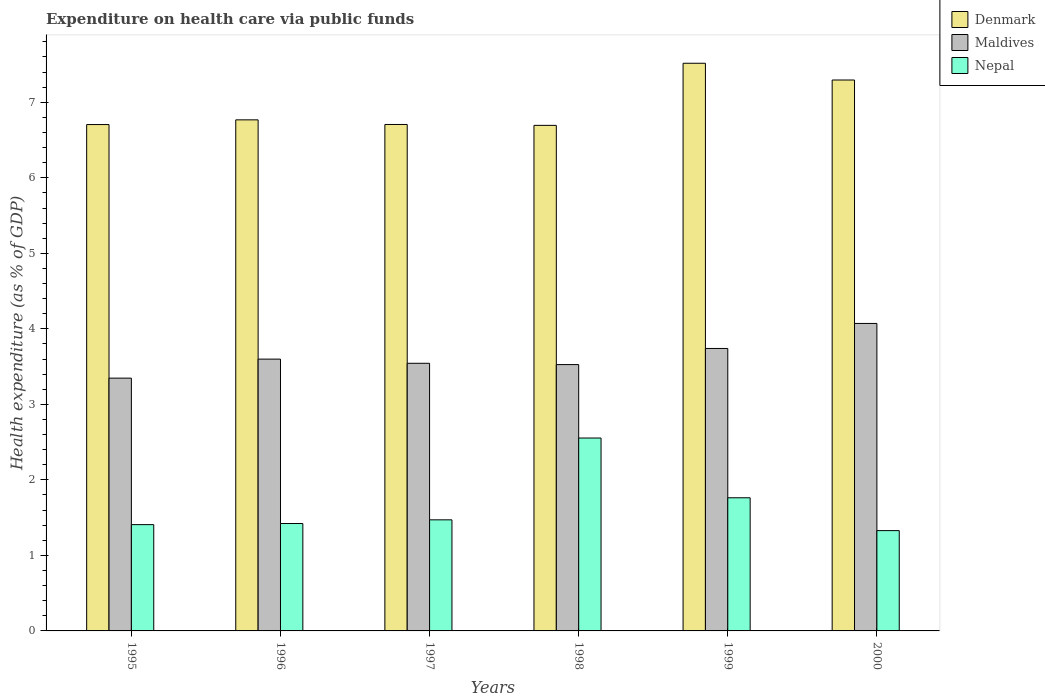How many groups of bars are there?
Provide a short and direct response. 6. Are the number of bars on each tick of the X-axis equal?
Make the answer very short. Yes. How many bars are there on the 3rd tick from the right?
Make the answer very short. 3. What is the label of the 2nd group of bars from the left?
Your response must be concise. 1996. What is the expenditure made on health care in Denmark in 1999?
Provide a short and direct response. 7.52. Across all years, what is the maximum expenditure made on health care in Denmark?
Give a very brief answer. 7.52. Across all years, what is the minimum expenditure made on health care in Nepal?
Your answer should be very brief. 1.33. In which year was the expenditure made on health care in Nepal maximum?
Offer a very short reply. 1998. What is the total expenditure made on health care in Denmark in the graph?
Give a very brief answer. 41.69. What is the difference between the expenditure made on health care in Maldives in 1998 and that in 1999?
Give a very brief answer. -0.21. What is the difference between the expenditure made on health care in Nepal in 2000 and the expenditure made on health care in Denmark in 1997?
Keep it short and to the point. -5.38. What is the average expenditure made on health care in Denmark per year?
Offer a terse response. 6.95. In the year 1999, what is the difference between the expenditure made on health care in Nepal and expenditure made on health care in Maldives?
Offer a very short reply. -1.98. In how many years, is the expenditure made on health care in Nepal greater than 6.4 %?
Provide a short and direct response. 0. What is the ratio of the expenditure made on health care in Denmark in 1995 to that in 2000?
Provide a short and direct response. 0.92. Is the expenditure made on health care in Maldives in 1995 less than that in 1998?
Your answer should be compact. Yes. What is the difference between the highest and the second highest expenditure made on health care in Nepal?
Make the answer very short. 0.79. What is the difference between the highest and the lowest expenditure made on health care in Maldives?
Your answer should be compact. 0.72. In how many years, is the expenditure made on health care in Nepal greater than the average expenditure made on health care in Nepal taken over all years?
Give a very brief answer. 2. Is the sum of the expenditure made on health care in Nepal in 1995 and 1998 greater than the maximum expenditure made on health care in Maldives across all years?
Your response must be concise. No. What does the 2nd bar from the left in 1996 represents?
Your answer should be compact. Maldives. What does the 1st bar from the right in 1998 represents?
Your answer should be compact. Nepal. Is it the case that in every year, the sum of the expenditure made on health care in Denmark and expenditure made on health care in Maldives is greater than the expenditure made on health care in Nepal?
Give a very brief answer. Yes. How many bars are there?
Keep it short and to the point. 18. Are all the bars in the graph horizontal?
Ensure brevity in your answer.  No. What is the difference between two consecutive major ticks on the Y-axis?
Your answer should be very brief. 1. Are the values on the major ticks of Y-axis written in scientific E-notation?
Your answer should be very brief. No. Does the graph contain grids?
Make the answer very short. No. Where does the legend appear in the graph?
Your answer should be compact. Top right. How are the legend labels stacked?
Make the answer very short. Vertical. What is the title of the graph?
Your answer should be very brief. Expenditure on health care via public funds. What is the label or title of the X-axis?
Provide a short and direct response. Years. What is the label or title of the Y-axis?
Keep it short and to the point. Health expenditure (as % of GDP). What is the Health expenditure (as % of GDP) of Denmark in 1995?
Your answer should be compact. 6.71. What is the Health expenditure (as % of GDP) in Maldives in 1995?
Offer a terse response. 3.35. What is the Health expenditure (as % of GDP) in Nepal in 1995?
Your answer should be very brief. 1.41. What is the Health expenditure (as % of GDP) of Denmark in 1996?
Your answer should be very brief. 6.77. What is the Health expenditure (as % of GDP) of Maldives in 1996?
Keep it short and to the point. 3.6. What is the Health expenditure (as % of GDP) in Nepal in 1996?
Provide a succinct answer. 1.42. What is the Health expenditure (as % of GDP) in Denmark in 1997?
Offer a very short reply. 6.71. What is the Health expenditure (as % of GDP) of Maldives in 1997?
Your answer should be compact. 3.54. What is the Health expenditure (as % of GDP) of Nepal in 1997?
Provide a succinct answer. 1.47. What is the Health expenditure (as % of GDP) of Denmark in 1998?
Your answer should be very brief. 6.69. What is the Health expenditure (as % of GDP) in Maldives in 1998?
Your response must be concise. 3.53. What is the Health expenditure (as % of GDP) of Nepal in 1998?
Offer a terse response. 2.55. What is the Health expenditure (as % of GDP) in Denmark in 1999?
Ensure brevity in your answer.  7.52. What is the Health expenditure (as % of GDP) of Maldives in 1999?
Provide a succinct answer. 3.74. What is the Health expenditure (as % of GDP) in Nepal in 1999?
Offer a very short reply. 1.76. What is the Health expenditure (as % of GDP) in Denmark in 2000?
Your response must be concise. 7.3. What is the Health expenditure (as % of GDP) of Maldives in 2000?
Give a very brief answer. 4.07. What is the Health expenditure (as % of GDP) in Nepal in 2000?
Keep it short and to the point. 1.33. Across all years, what is the maximum Health expenditure (as % of GDP) of Denmark?
Your answer should be very brief. 7.52. Across all years, what is the maximum Health expenditure (as % of GDP) of Maldives?
Ensure brevity in your answer.  4.07. Across all years, what is the maximum Health expenditure (as % of GDP) in Nepal?
Ensure brevity in your answer.  2.55. Across all years, what is the minimum Health expenditure (as % of GDP) in Denmark?
Ensure brevity in your answer.  6.69. Across all years, what is the minimum Health expenditure (as % of GDP) in Maldives?
Your response must be concise. 3.35. Across all years, what is the minimum Health expenditure (as % of GDP) in Nepal?
Make the answer very short. 1.33. What is the total Health expenditure (as % of GDP) in Denmark in the graph?
Your answer should be compact. 41.69. What is the total Health expenditure (as % of GDP) of Maldives in the graph?
Offer a very short reply. 21.83. What is the total Health expenditure (as % of GDP) of Nepal in the graph?
Provide a short and direct response. 9.95. What is the difference between the Health expenditure (as % of GDP) of Denmark in 1995 and that in 1996?
Your answer should be compact. -0.06. What is the difference between the Health expenditure (as % of GDP) in Maldives in 1995 and that in 1996?
Your response must be concise. -0.25. What is the difference between the Health expenditure (as % of GDP) of Nepal in 1995 and that in 1996?
Make the answer very short. -0.01. What is the difference between the Health expenditure (as % of GDP) in Denmark in 1995 and that in 1997?
Your answer should be compact. -0. What is the difference between the Health expenditure (as % of GDP) of Maldives in 1995 and that in 1997?
Keep it short and to the point. -0.2. What is the difference between the Health expenditure (as % of GDP) of Nepal in 1995 and that in 1997?
Keep it short and to the point. -0.06. What is the difference between the Health expenditure (as % of GDP) in Denmark in 1995 and that in 1998?
Provide a succinct answer. 0.01. What is the difference between the Health expenditure (as % of GDP) in Maldives in 1995 and that in 1998?
Provide a short and direct response. -0.18. What is the difference between the Health expenditure (as % of GDP) of Nepal in 1995 and that in 1998?
Ensure brevity in your answer.  -1.15. What is the difference between the Health expenditure (as % of GDP) of Denmark in 1995 and that in 1999?
Your answer should be compact. -0.81. What is the difference between the Health expenditure (as % of GDP) in Maldives in 1995 and that in 1999?
Keep it short and to the point. -0.39. What is the difference between the Health expenditure (as % of GDP) of Nepal in 1995 and that in 1999?
Keep it short and to the point. -0.36. What is the difference between the Health expenditure (as % of GDP) in Denmark in 1995 and that in 2000?
Ensure brevity in your answer.  -0.59. What is the difference between the Health expenditure (as % of GDP) of Maldives in 1995 and that in 2000?
Ensure brevity in your answer.  -0.72. What is the difference between the Health expenditure (as % of GDP) of Nepal in 1995 and that in 2000?
Keep it short and to the point. 0.08. What is the difference between the Health expenditure (as % of GDP) of Denmark in 1996 and that in 1997?
Offer a terse response. 0.06. What is the difference between the Health expenditure (as % of GDP) of Maldives in 1996 and that in 1997?
Provide a succinct answer. 0.06. What is the difference between the Health expenditure (as % of GDP) in Nepal in 1996 and that in 1997?
Provide a short and direct response. -0.05. What is the difference between the Health expenditure (as % of GDP) in Denmark in 1996 and that in 1998?
Your answer should be compact. 0.07. What is the difference between the Health expenditure (as % of GDP) of Maldives in 1996 and that in 1998?
Your response must be concise. 0.07. What is the difference between the Health expenditure (as % of GDP) in Nepal in 1996 and that in 1998?
Your answer should be very brief. -1.13. What is the difference between the Health expenditure (as % of GDP) of Denmark in 1996 and that in 1999?
Keep it short and to the point. -0.75. What is the difference between the Health expenditure (as % of GDP) in Maldives in 1996 and that in 1999?
Ensure brevity in your answer.  -0.14. What is the difference between the Health expenditure (as % of GDP) in Nepal in 1996 and that in 1999?
Give a very brief answer. -0.34. What is the difference between the Health expenditure (as % of GDP) in Denmark in 1996 and that in 2000?
Provide a short and direct response. -0.53. What is the difference between the Health expenditure (as % of GDP) of Maldives in 1996 and that in 2000?
Keep it short and to the point. -0.47. What is the difference between the Health expenditure (as % of GDP) in Nepal in 1996 and that in 2000?
Offer a terse response. 0.09. What is the difference between the Health expenditure (as % of GDP) in Denmark in 1997 and that in 1998?
Provide a succinct answer. 0.01. What is the difference between the Health expenditure (as % of GDP) in Maldives in 1997 and that in 1998?
Your response must be concise. 0.02. What is the difference between the Health expenditure (as % of GDP) in Nepal in 1997 and that in 1998?
Your response must be concise. -1.08. What is the difference between the Health expenditure (as % of GDP) in Denmark in 1997 and that in 1999?
Provide a succinct answer. -0.81. What is the difference between the Health expenditure (as % of GDP) in Maldives in 1997 and that in 1999?
Offer a terse response. -0.2. What is the difference between the Health expenditure (as % of GDP) of Nepal in 1997 and that in 1999?
Your answer should be very brief. -0.29. What is the difference between the Health expenditure (as % of GDP) in Denmark in 1997 and that in 2000?
Provide a short and direct response. -0.59. What is the difference between the Health expenditure (as % of GDP) in Maldives in 1997 and that in 2000?
Give a very brief answer. -0.53. What is the difference between the Health expenditure (as % of GDP) of Nepal in 1997 and that in 2000?
Ensure brevity in your answer.  0.14. What is the difference between the Health expenditure (as % of GDP) of Denmark in 1998 and that in 1999?
Provide a succinct answer. -0.82. What is the difference between the Health expenditure (as % of GDP) of Maldives in 1998 and that in 1999?
Ensure brevity in your answer.  -0.21. What is the difference between the Health expenditure (as % of GDP) in Nepal in 1998 and that in 1999?
Offer a terse response. 0.79. What is the difference between the Health expenditure (as % of GDP) of Denmark in 1998 and that in 2000?
Provide a short and direct response. -0.6. What is the difference between the Health expenditure (as % of GDP) of Maldives in 1998 and that in 2000?
Offer a terse response. -0.54. What is the difference between the Health expenditure (as % of GDP) in Nepal in 1998 and that in 2000?
Ensure brevity in your answer.  1.23. What is the difference between the Health expenditure (as % of GDP) in Denmark in 1999 and that in 2000?
Provide a short and direct response. 0.22. What is the difference between the Health expenditure (as % of GDP) in Maldives in 1999 and that in 2000?
Give a very brief answer. -0.33. What is the difference between the Health expenditure (as % of GDP) of Nepal in 1999 and that in 2000?
Your response must be concise. 0.44. What is the difference between the Health expenditure (as % of GDP) in Denmark in 1995 and the Health expenditure (as % of GDP) in Maldives in 1996?
Give a very brief answer. 3.11. What is the difference between the Health expenditure (as % of GDP) of Denmark in 1995 and the Health expenditure (as % of GDP) of Nepal in 1996?
Your response must be concise. 5.28. What is the difference between the Health expenditure (as % of GDP) in Maldives in 1995 and the Health expenditure (as % of GDP) in Nepal in 1996?
Provide a short and direct response. 1.93. What is the difference between the Health expenditure (as % of GDP) in Denmark in 1995 and the Health expenditure (as % of GDP) in Maldives in 1997?
Ensure brevity in your answer.  3.16. What is the difference between the Health expenditure (as % of GDP) of Denmark in 1995 and the Health expenditure (as % of GDP) of Nepal in 1997?
Keep it short and to the point. 5.23. What is the difference between the Health expenditure (as % of GDP) in Maldives in 1995 and the Health expenditure (as % of GDP) in Nepal in 1997?
Your response must be concise. 1.88. What is the difference between the Health expenditure (as % of GDP) in Denmark in 1995 and the Health expenditure (as % of GDP) in Maldives in 1998?
Ensure brevity in your answer.  3.18. What is the difference between the Health expenditure (as % of GDP) in Denmark in 1995 and the Health expenditure (as % of GDP) in Nepal in 1998?
Offer a very short reply. 4.15. What is the difference between the Health expenditure (as % of GDP) in Maldives in 1995 and the Health expenditure (as % of GDP) in Nepal in 1998?
Your answer should be very brief. 0.79. What is the difference between the Health expenditure (as % of GDP) in Denmark in 1995 and the Health expenditure (as % of GDP) in Maldives in 1999?
Your answer should be compact. 2.97. What is the difference between the Health expenditure (as % of GDP) in Denmark in 1995 and the Health expenditure (as % of GDP) in Nepal in 1999?
Provide a succinct answer. 4.94. What is the difference between the Health expenditure (as % of GDP) in Maldives in 1995 and the Health expenditure (as % of GDP) in Nepal in 1999?
Provide a succinct answer. 1.58. What is the difference between the Health expenditure (as % of GDP) of Denmark in 1995 and the Health expenditure (as % of GDP) of Maldives in 2000?
Provide a short and direct response. 2.63. What is the difference between the Health expenditure (as % of GDP) of Denmark in 1995 and the Health expenditure (as % of GDP) of Nepal in 2000?
Make the answer very short. 5.38. What is the difference between the Health expenditure (as % of GDP) in Maldives in 1995 and the Health expenditure (as % of GDP) in Nepal in 2000?
Ensure brevity in your answer.  2.02. What is the difference between the Health expenditure (as % of GDP) in Denmark in 1996 and the Health expenditure (as % of GDP) in Maldives in 1997?
Provide a succinct answer. 3.22. What is the difference between the Health expenditure (as % of GDP) in Denmark in 1996 and the Health expenditure (as % of GDP) in Nepal in 1997?
Give a very brief answer. 5.3. What is the difference between the Health expenditure (as % of GDP) of Maldives in 1996 and the Health expenditure (as % of GDP) of Nepal in 1997?
Ensure brevity in your answer.  2.13. What is the difference between the Health expenditure (as % of GDP) in Denmark in 1996 and the Health expenditure (as % of GDP) in Maldives in 1998?
Provide a short and direct response. 3.24. What is the difference between the Health expenditure (as % of GDP) of Denmark in 1996 and the Health expenditure (as % of GDP) of Nepal in 1998?
Offer a terse response. 4.21. What is the difference between the Health expenditure (as % of GDP) of Maldives in 1996 and the Health expenditure (as % of GDP) of Nepal in 1998?
Ensure brevity in your answer.  1.04. What is the difference between the Health expenditure (as % of GDP) in Denmark in 1996 and the Health expenditure (as % of GDP) in Maldives in 1999?
Make the answer very short. 3.03. What is the difference between the Health expenditure (as % of GDP) of Denmark in 1996 and the Health expenditure (as % of GDP) of Nepal in 1999?
Offer a terse response. 5. What is the difference between the Health expenditure (as % of GDP) in Maldives in 1996 and the Health expenditure (as % of GDP) in Nepal in 1999?
Your answer should be compact. 1.84. What is the difference between the Health expenditure (as % of GDP) of Denmark in 1996 and the Health expenditure (as % of GDP) of Maldives in 2000?
Offer a very short reply. 2.7. What is the difference between the Health expenditure (as % of GDP) in Denmark in 1996 and the Health expenditure (as % of GDP) in Nepal in 2000?
Provide a succinct answer. 5.44. What is the difference between the Health expenditure (as % of GDP) in Maldives in 1996 and the Health expenditure (as % of GDP) in Nepal in 2000?
Your answer should be very brief. 2.27. What is the difference between the Health expenditure (as % of GDP) in Denmark in 1997 and the Health expenditure (as % of GDP) in Maldives in 1998?
Offer a terse response. 3.18. What is the difference between the Health expenditure (as % of GDP) in Denmark in 1997 and the Health expenditure (as % of GDP) in Nepal in 1998?
Keep it short and to the point. 4.15. What is the difference between the Health expenditure (as % of GDP) in Denmark in 1997 and the Health expenditure (as % of GDP) in Maldives in 1999?
Your response must be concise. 2.97. What is the difference between the Health expenditure (as % of GDP) in Denmark in 1997 and the Health expenditure (as % of GDP) in Nepal in 1999?
Your answer should be compact. 4.94. What is the difference between the Health expenditure (as % of GDP) in Maldives in 1997 and the Health expenditure (as % of GDP) in Nepal in 1999?
Offer a very short reply. 1.78. What is the difference between the Health expenditure (as % of GDP) of Denmark in 1997 and the Health expenditure (as % of GDP) of Maldives in 2000?
Your response must be concise. 2.63. What is the difference between the Health expenditure (as % of GDP) of Denmark in 1997 and the Health expenditure (as % of GDP) of Nepal in 2000?
Make the answer very short. 5.38. What is the difference between the Health expenditure (as % of GDP) of Maldives in 1997 and the Health expenditure (as % of GDP) of Nepal in 2000?
Your response must be concise. 2.22. What is the difference between the Health expenditure (as % of GDP) in Denmark in 1998 and the Health expenditure (as % of GDP) in Maldives in 1999?
Give a very brief answer. 2.95. What is the difference between the Health expenditure (as % of GDP) in Denmark in 1998 and the Health expenditure (as % of GDP) in Nepal in 1999?
Ensure brevity in your answer.  4.93. What is the difference between the Health expenditure (as % of GDP) of Maldives in 1998 and the Health expenditure (as % of GDP) of Nepal in 1999?
Your answer should be compact. 1.76. What is the difference between the Health expenditure (as % of GDP) in Denmark in 1998 and the Health expenditure (as % of GDP) in Maldives in 2000?
Keep it short and to the point. 2.62. What is the difference between the Health expenditure (as % of GDP) of Denmark in 1998 and the Health expenditure (as % of GDP) of Nepal in 2000?
Your answer should be compact. 5.37. What is the difference between the Health expenditure (as % of GDP) in Maldives in 1998 and the Health expenditure (as % of GDP) in Nepal in 2000?
Provide a succinct answer. 2.2. What is the difference between the Health expenditure (as % of GDP) of Denmark in 1999 and the Health expenditure (as % of GDP) of Maldives in 2000?
Offer a terse response. 3.45. What is the difference between the Health expenditure (as % of GDP) in Denmark in 1999 and the Health expenditure (as % of GDP) in Nepal in 2000?
Provide a succinct answer. 6.19. What is the difference between the Health expenditure (as % of GDP) of Maldives in 1999 and the Health expenditure (as % of GDP) of Nepal in 2000?
Your answer should be very brief. 2.41. What is the average Health expenditure (as % of GDP) of Denmark per year?
Keep it short and to the point. 6.95. What is the average Health expenditure (as % of GDP) in Maldives per year?
Your response must be concise. 3.64. What is the average Health expenditure (as % of GDP) in Nepal per year?
Provide a succinct answer. 1.66. In the year 1995, what is the difference between the Health expenditure (as % of GDP) of Denmark and Health expenditure (as % of GDP) of Maldives?
Ensure brevity in your answer.  3.36. In the year 1995, what is the difference between the Health expenditure (as % of GDP) in Denmark and Health expenditure (as % of GDP) in Nepal?
Your answer should be compact. 5.3. In the year 1995, what is the difference between the Health expenditure (as % of GDP) of Maldives and Health expenditure (as % of GDP) of Nepal?
Your answer should be compact. 1.94. In the year 1996, what is the difference between the Health expenditure (as % of GDP) in Denmark and Health expenditure (as % of GDP) in Maldives?
Make the answer very short. 3.17. In the year 1996, what is the difference between the Health expenditure (as % of GDP) in Denmark and Health expenditure (as % of GDP) in Nepal?
Your answer should be very brief. 5.35. In the year 1996, what is the difference between the Health expenditure (as % of GDP) in Maldives and Health expenditure (as % of GDP) in Nepal?
Your answer should be very brief. 2.18. In the year 1997, what is the difference between the Health expenditure (as % of GDP) of Denmark and Health expenditure (as % of GDP) of Maldives?
Your answer should be very brief. 3.16. In the year 1997, what is the difference between the Health expenditure (as % of GDP) in Denmark and Health expenditure (as % of GDP) in Nepal?
Make the answer very short. 5.24. In the year 1997, what is the difference between the Health expenditure (as % of GDP) in Maldives and Health expenditure (as % of GDP) in Nepal?
Make the answer very short. 2.07. In the year 1998, what is the difference between the Health expenditure (as % of GDP) of Denmark and Health expenditure (as % of GDP) of Maldives?
Your answer should be very brief. 3.17. In the year 1998, what is the difference between the Health expenditure (as % of GDP) of Denmark and Health expenditure (as % of GDP) of Nepal?
Offer a very short reply. 4.14. In the year 1998, what is the difference between the Health expenditure (as % of GDP) in Maldives and Health expenditure (as % of GDP) in Nepal?
Provide a succinct answer. 0.97. In the year 1999, what is the difference between the Health expenditure (as % of GDP) in Denmark and Health expenditure (as % of GDP) in Maldives?
Provide a succinct answer. 3.78. In the year 1999, what is the difference between the Health expenditure (as % of GDP) of Denmark and Health expenditure (as % of GDP) of Nepal?
Offer a terse response. 5.75. In the year 1999, what is the difference between the Health expenditure (as % of GDP) in Maldives and Health expenditure (as % of GDP) in Nepal?
Ensure brevity in your answer.  1.98. In the year 2000, what is the difference between the Health expenditure (as % of GDP) of Denmark and Health expenditure (as % of GDP) of Maldives?
Offer a very short reply. 3.22. In the year 2000, what is the difference between the Health expenditure (as % of GDP) in Denmark and Health expenditure (as % of GDP) in Nepal?
Your answer should be very brief. 5.97. In the year 2000, what is the difference between the Health expenditure (as % of GDP) in Maldives and Health expenditure (as % of GDP) in Nepal?
Make the answer very short. 2.74. What is the ratio of the Health expenditure (as % of GDP) of Maldives in 1995 to that in 1996?
Keep it short and to the point. 0.93. What is the ratio of the Health expenditure (as % of GDP) in Denmark in 1995 to that in 1997?
Make the answer very short. 1. What is the ratio of the Health expenditure (as % of GDP) in Maldives in 1995 to that in 1997?
Keep it short and to the point. 0.94. What is the ratio of the Health expenditure (as % of GDP) of Nepal in 1995 to that in 1997?
Provide a succinct answer. 0.96. What is the ratio of the Health expenditure (as % of GDP) in Denmark in 1995 to that in 1998?
Keep it short and to the point. 1. What is the ratio of the Health expenditure (as % of GDP) in Maldives in 1995 to that in 1998?
Keep it short and to the point. 0.95. What is the ratio of the Health expenditure (as % of GDP) of Nepal in 1995 to that in 1998?
Give a very brief answer. 0.55. What is the ratio of the Health expenditure (as % of GDP) in Denmark in 1995 to that in 1999?
Offer a very short reply. 0.89. What is the ratio of the Health expenditure (as % of GDP) in Maldives in 1995 to that in 1999?
Ensure brevity in your answer.  0.9. What is the ratio of the Health expenditure (as % of GDP) in Nepal in 1995 to that in 1999?
Offer a terse response. 0.8. What is the ratio of the Health expenditure (as % of GDP) in Denmark in 1995 to that in 2000?
Your answer should be compact. 0.92. What is the ratio of the Health expenditure (as % of GDP) in Maldives in 1995 to that in 2000?
Your response must be concise. 0.82. What is the ratio of the Health expenditure (as % of GDP) in Nepal in 1995 to that in 2000?
Provide a short and direct response. 1.06. What is the ratio of the Health expenditure (as % of GDP) in Denmark in 1996 to that in 1997?
Offer a terse response. 1.01. What is the ratio of the Health expenditure (as % of GDP) in Maldives in 1996 to that in 1997?
Your answer should be very brief. 1.02. What is the ratio of the Health expenditure (as % of GDP) of Nepal in 1996 to that in 1997?
Offer a very short reply. 0.97. What is the ratio of the Health expenditure (as % of GDP) in Denmark in 1996 to that in 1998?
Make the answer very short. 1.01. What is the ratio of the Health expenditure (as % of GDP) of Maldives in 1996 to that in 1998?
Offer a terse response. 1.02. What is the ratio of the Health expenditure (as % of GDP) in Nepal in 1996 to that in 1998?
Your response must be concise. 0.56. What is the ratio of the Health expenditure (as % of GDP) in Denmark in 1996 to that in 1999?
Make the answer very short. 0.9. What is the ratio of the Health expenditure (as % of GDP) in Maldives in 1996 to that in 1999?
Your answer should be very brief. 0.96. What is the ratio of the Health expenditure (as % of GDP) of Nepal in 1996 to that in 1999?
Provide a short and direct response. 0.81. What is the ratio of the Health expenditure (as % of GDP) of Denmark in 1996 to that in 2000?
Your answer should be compact. 0.93. What is the ratio of the Health expenditure (as % of GDP) of Maldives in 1996 to that in 2000?
Give a very brief answer. 0.88. What is the ratio of the Health expenditure (as % of GDP) of Nepal in 1996 to that in 2000?
Offer a terse response. 1.07. What is the ratio of the Health expenditure (as % of GDP) of Nepal in 1997 to that in 1998?
Ensure brevity in your answer.  0.58. What is the ratio of the Health expenditure (as % of GDP) in Denmark in 1997 to that in 1999?
Keep it short and to the point. 0.89. What is the ratio of the Health expenditure (as % of GDP) in Maldives in 1997 to that in 1999?
Your answer should be very brief. 0.95. What is the ratio of the Health expenditure (as % of GDP) of Nepal in 1997 to that in 1999?
Give a very brief answer. 0.83. What is the ratio of the Health expenditure (as % of GDP) in Denmark in 1997 to that in 2000?
Offer a terse response. 0.92. What is the ratio of the Health expenditure (as % of GDP) in Maldives in 1997 to that in 2000?
Provide a short and direct response. 0.87. What is the ratio of the Health expenditure (as % of GDP) of Nepal in 1997 to that in 2000?
Provide a succinct answer. 1.11. What is the ratio of the Health expenditure (as % of GDP) in Denmark in 1998 to that in 1999?
Your answer should be very brief. 0.89. What is the ratio of the Health expenditure (as % of GDP) of Maldives in 1998 to that in 1999?
Provide a succinct answer. 0.94. What is the ratio of the Health expenditure (as % of GDP) of Nepal in 1998 to that in 1999?
Provide a short and direct response. 1.45. What is the ratio of the Health expenditure (as % of GDP) of Denmark in 1998 to that in 2000?
Give a very brief answer. 0.92. What is the ratio of the Health expenditure (as % of GDP) of Maldives in 1998 to that in 2000?
Ensure brevity in your answer.  0.87. What is the ratio of the Health expenditure (as % of GDP) of Nepal in 1998 to that in 2000?
Keep it short and to the point. 1.92. What is the ratio of the Health expenditure (as % of GDP) of Denmark in 1999 to that in 2000?
Your response must be concise. 1.03. What is the ratio of the Health expenditure (as % of GDP) of Maldives in 1999 to that in 2000?
Your answer should be compact. 0.92. What is the ratio of the Health expenditure (as % of GDP) in Nepal in 1999 to that in 2000?
Your response must be concise. 1.33. What is the difference between the highest and the second highest Health expenditure (as % of GDP) of Denmark?
Your response must be concise. 0.22. What is the difference between the highest and the second highest Health expenditure (as % of GDP) of Maldives?
Your response must be concise. 0.33. What is the difference between the highest and the second highest Health expenditure (as % of GDP) of Nepal?
Ensure brevity in your answer.  0.79. What is the difference between the highest and the lowest Health expenditure (as % of GDP) of Denmark?
Offer a very short reply. 0.82. What is the difference between the highest and the lowest Health expenditure (as % of GDP) of Maldives?
Your answer should be compact. 0.72. What is the difference between the highest and the lowest Health expenditure (as % of GDP) in Nepal?
Make the answer very short. 1.23. 